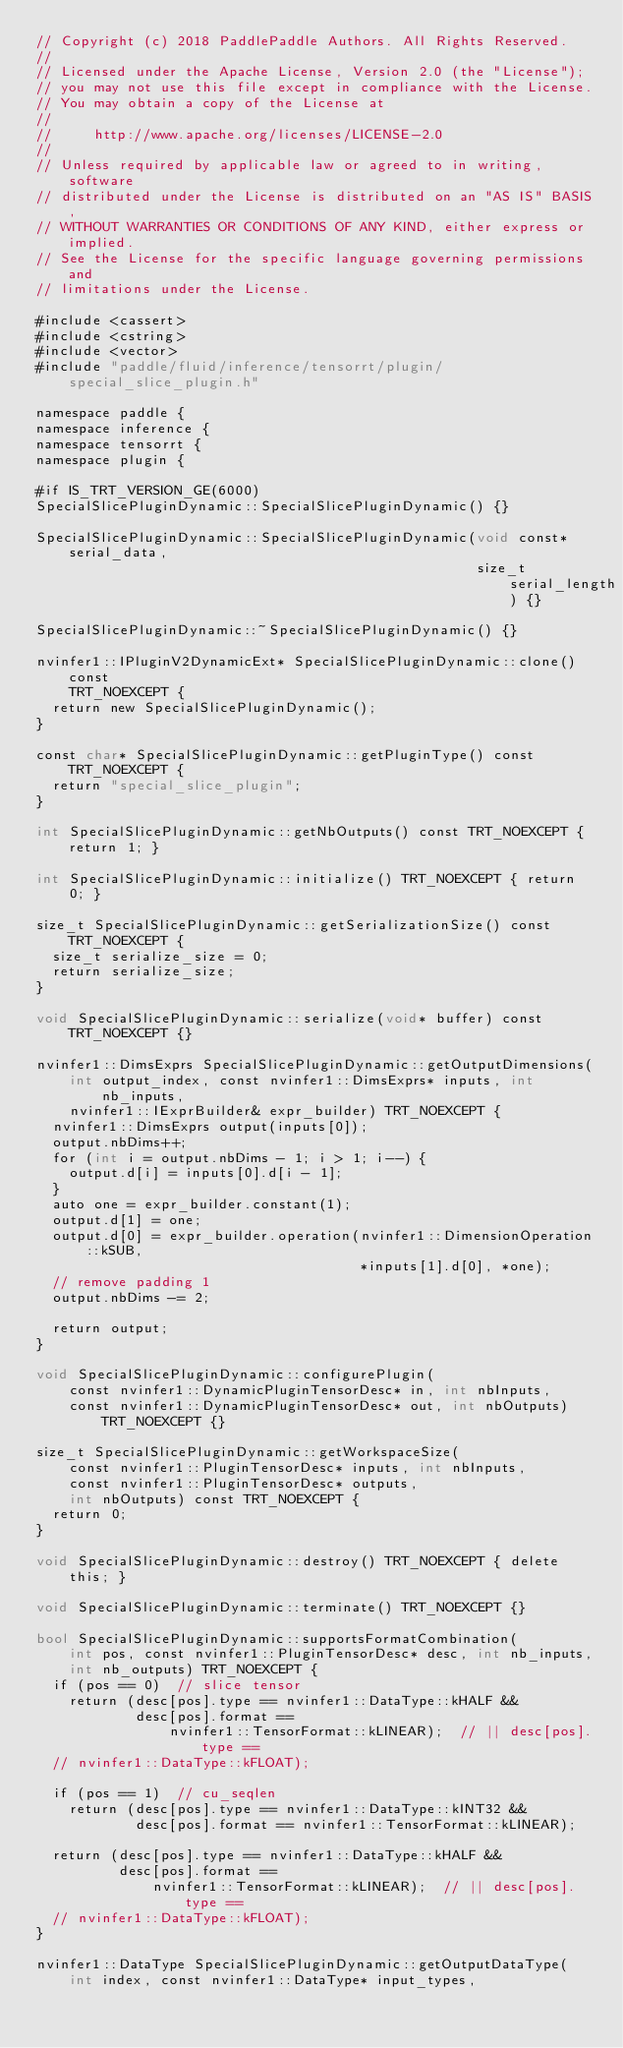Convert code to text. <code><loc_0><loc_0><loc_500><loc_500><_Cuda_>// Copyright (c) 2018 PaddlePaddle Authors. All Rights Reserved.
//
// Licensed under the Apache License, Version 2.0 (the "License");
// you may not use this file except in compliance with the License.
// You may obtain a copy of the License at
//
//     http://www.apache.org/licenses/LICENSE-2.0
//
// Unless required by applicable law or agreed to in writing, software
// distributed under the License is distributed on an "AS IS" BASIS,
// WITHOUT WARRANTIES OR CONDITIONS OF ANY KIND, either express or implied.
// See the License for the specific language governing permissions and
// limitations under the License.

#include <cassert>
#include <cstring>
#include <vector>
#include "paddle/fluid/inference/tensorrt/plugin/special_slice_plugin.h"

namespace paddle {
namespace inference {
namespace tensorrt {
namespace plugin {

#if IS_TRT_VERSION_GE(6000)
SpecialSlicePluginDynamic::SpecialSlicePluginDynamic() {}

SpecialSlicePluginDynamic::SpecialSlicePluginDynamic(void const* serial_data,
                                                     size_t serial_length) {}

SpecialSlicePluginDynamic::~SpecialSlicePluginDynamic() {}

nvinfer1::IPluginV2DynamicExt* SpecialSlicePluginDynamic::clone() const
    TRT_NOEXCEPT {
  return new SpecialSlicePluginDynamic();
}

const char* SpecialSlicePluginDynamic::getPluginType() const TRT_NOEXCEPT {
  return "special_slice_plugin";
}

int SpecialSlicePluginDynamic::getNbOutputs() const TRT_NOEXCEPT { return 1; }

int SpecialSlicePluginDynamic::initialize() TRT_NOEXCEPT { return 0; }

size_t SpecialSlicePluginDynamic::getSerializationSize() const TRT_NOEXCEPT {
  size_t serialize_size = 0;
  return serialize_size;
}

void SpecialSlicePluginDynamic::serialize(void* buffer) const TRT_NOEXCEPT {}

nvinfer1::DimsExprs SpecialSlicePluginDynamic::getOutputDimensions(
    int output_index, const nvinfer1::DimsExprs* inputs, int nb_inputs,
    nvinfer1::IExprBuilder& expr_builder) TRT_NOEXCEPT {
  nvinfer1::DimsExprs output(inputs[0]);
  output.nbDims++;
  for (int i = output.nbDims - 1; i > 1; i--) {
    output.d[i] = inputs[0].d[i - 1];
  }
  auto one = expr_builder.constant(1);
  output.d[1] = one;
  output.d[0] = expr_builder.operation(nvinfer1::DimensionOperation::kSUB,
                                       *inputs[1].d[0], *one);
  // remove padding 1
  output.nbDims -= 2;

  return output;
}

void SpecialSlicePluginDynamic::configurePlugin(
    const nvinfer1::DynamicPluginTensorDesc* in, int nbInputs,
    const nvinfer1::DynamicPluginTensorDesc* out, int nbOutputs) TRT_NOEXCEPT {}

size_t SpecialSlicePluginDynamic::getWorkspaceSize(
    const nvinfer1::PluginTensorDesc* inputs, int nbInputs,
    const nvinfer1::PluginTensorDesc* outputs,
    int nbOutputs) const TRT_NOEXCEPT {
  return 0;
}

void SpecialSlicePluginDynamic::destroy() TRT_NOEXCEPT { delete this; }

void SpecialSlicePluginDynamic::terminate() TRT_NOEXCEPT {}

bool SpecialSlicePluginDynamic::supportsFormatCombination(
    int pos, const nvinfer1::PluginTensorDesc* desc, int nb_inputs,
    int nb_outputs) TRT_NOEXCEPT {
  if (pos == 0)  // slice tensor
    return (desc[pos].type == nvinfer1::DataType::kHALF &&
            desc[pos].format ==
                nvinfer1::TensorFormat::kLINEAR);  // || desc[pos].type ==
  // nvinfer1::DataType::kFLOAT);

  if (pos == 1)  // cu_seqlen
    return (desc[pos].type == nvinfer1::DataType::kINT32 &&
            desc[pos].format == nvinfer1::TensorFormat::kLINEAR);

  return (desc[pos].type == nvinfer1::DataType::kHALF &&
          desc[pos].format ==
              nvinfer1::TensorFormat::kLINEAR);  // || desc[pos].type ==
  // nvinfer1::DataType::kFLOAT);
}

nvinfer1::DataType SpecialSlicePluginDynamic::getOutputDataType(
    int index, const nvinfer1::DataType* input_types,</code> 